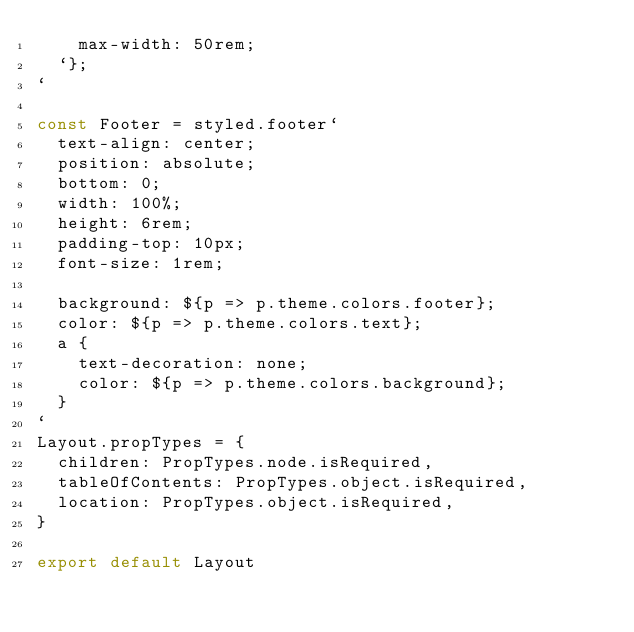Convert code to text. <code><loc_0><loc_0><loc_500><loc_500><_JavaScript_>    max-width: 50rem;
  `};
`

const Footer = styled.footer`
  text-align: center;
  position: absolute;
  bottom: 0;
  width: 100%;
  height: 6rem;
  padding-top: 10px;
  font-size: 1rem;

  background: ${p => p.theme.colors.footer};
  color: ${p => p.theme.colors.text};
  a {
    text-decoration: none;
    color: ${p => p.theme.colors.background};
  }
`
Layout.propTypes = {
  children: PropTypes.node.isRequired,
  tableOfContents: PropTypes.object.isRequired,
  location: PropTypes.object.isRequired,
}

export default Layout
</code> 